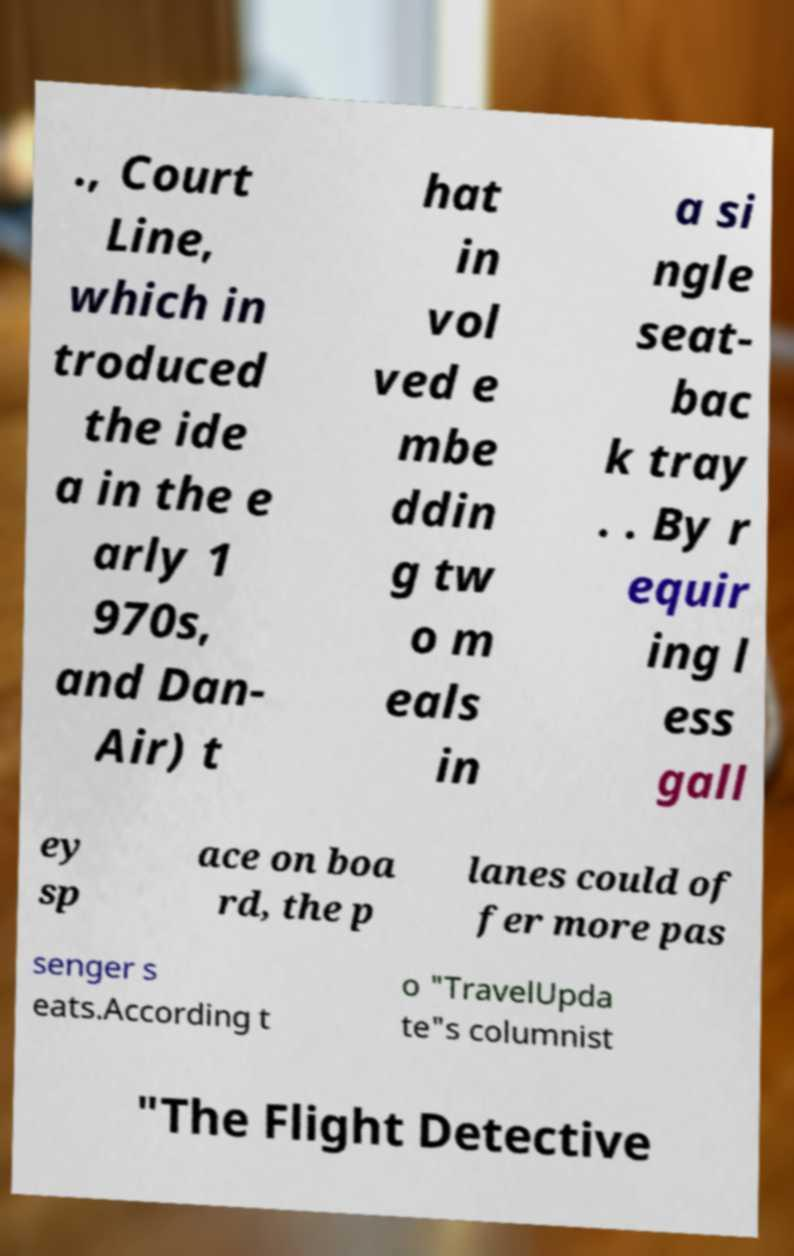Could you assist in decoding the text presented in this image and type it out clearly? ., Court Line, which in troduced the ide a in the e arly 1 970s, and Dan- Air) t hat in vol ved e mbe ddin g tw o m eals in a si ngle seat- bac k tray . . By r equir ing l ess gall ey sp ace on boa rd, the p lanes could of fer more pas senger s eats.According t o "TravelUpda te"s columnist "The Flight Detective 